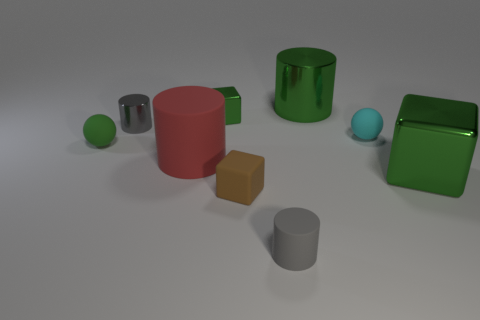Subtract all small blocks. How many blocks are left? 1 Subtract all cyan spheres. How many spheres are left? 1 Subtract 4 cylinders. How many cylinders are left? 0 Subtract all balls. How many objects are left? 7 Subtract all red cubes. How many purple cylinders are left? 0 Add 4 tiny gray things. How many tiny gray things are left? 6 Add 2 big green shiny cubes. How many big green shiny cubes exist? 3 Subtract 0 gray blocks. How many objects are left? 9 Subtract all green blocks. Subtract all green cylinders. How many blocks are left? 1 Subtract all purple matte cubes. Subtract all small gray cylinders. How many objects are left? 7 